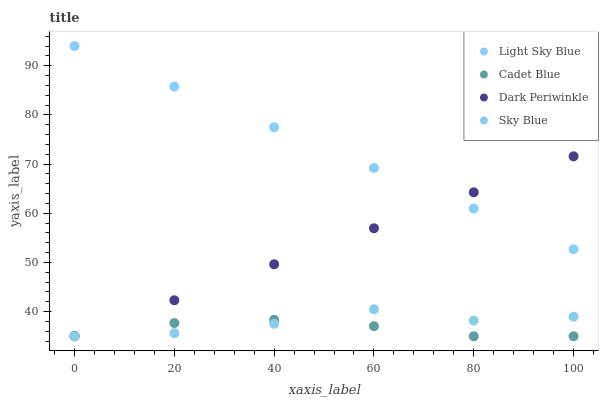Does Cadet Blue have the minimum area under the curve?
Answer yes or no. Yes. Does Light Sky Blue have the maximum area under the curve?
Answer yes or no. Yes. Does Sky Blue have the minimum area under the curve?
Answer yes or no. No. Does Sky Blue have the maximum area under the curve?
Answer yes or no. No. Is Dark Periwinkle the smoothest?
Answer yes or no. Yes. Is Sky Blue the roughest?
Answer yes or no. Yes. Is Light Sky Blue the smoothest?
Answer yes or no. No. Is Light Sky Blue the roughest?
Answer yes or no. No. Does Cadet Blue have the lowest value?
Answer yes or no. Yes. Does Light Sky Blue have the lowest value?
Answer yes or no. No. Does Light Sky Blue have the highest value?
Answer yes or no. Yes. Does Sky Blue have the highest value?
Answer yes or no. No. Is Cadet Blue less than Light Sky Blue?
Answer yes or no. Yes. Is Light Sky Blue greater than Sky Blue?
Answer yes or no. Yes. Does Cadet Blue intersect Dark Periwinkle?
Answer yes or no. Yes. Is Cadet Blue less than Dark Periwinkle?
Answer yes or no. No. Is Cadet Blue greater than Dark Periwinkle?
Answer yes or no. No. Does Cadet Blue intersect Light Sky Blue?
Answer yes or no. No. 